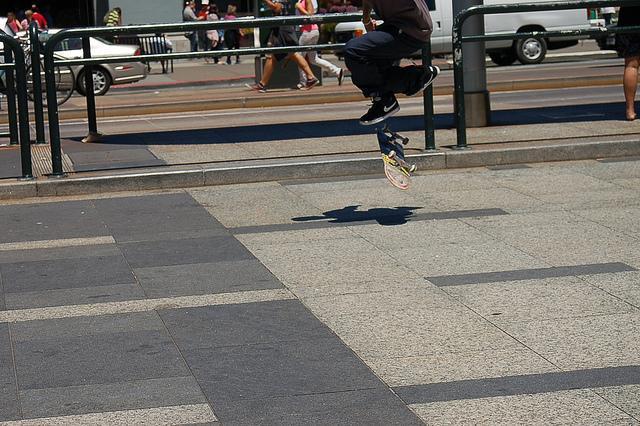How many people are in the picture?
Give a very brief answer. 2. How many cars are in the picture?
Give a very brief answer. 2. 